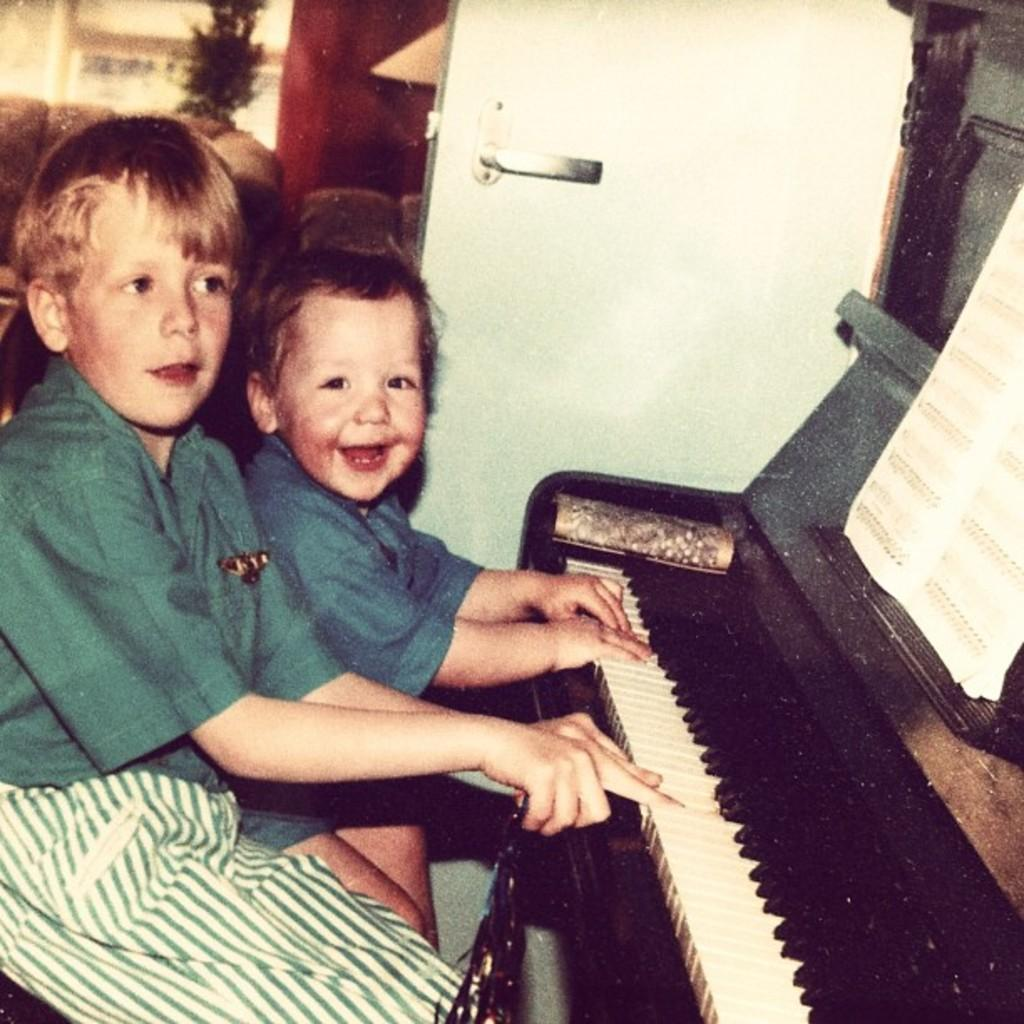How many kids are in the image? There are two kids in the image. What are the kids doing in the image? The kids are playing a musical instrument and smiling. Can you describe an object on the right side of the image? There is a book on the right side of the image. What can be seen in the background of the image? There is a door, a sofa, a couch, a plant, a wall, and a window in the background of the image. What color are the kids' son's toes in the image? There is no mention of a son or toes in the image, so we cannot answer this question. 